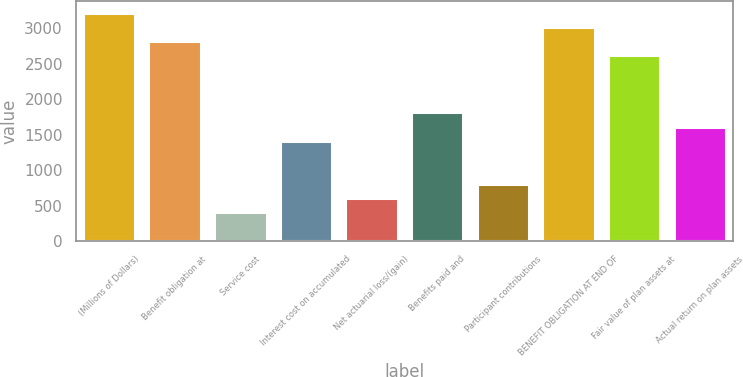<chart> <loc_0><loc_0><loc_500><loc_500><bar_chart><fcel>(Millions of Dollars)<fcel>Benefit obligation at<fcel>Service cost<fcel>Interest cost on accumulated<fcel>Net actuarial loss/(gain)<fcel>Benefits paid and<fcel>Participant contributions<fcel>BENEFIT OBLIGATION AT END OF<fcel>Fair value of plan assets at<fcel>Actual return on plan assets<nl><fcel>3218.2<fcel>2816.8<fcel>408.4<fcel>1411.9<fcel>609.1<fcel>1813.3<fcel>809.8<fcel>3017.5<fcel>2616.1<fcel>1612.6<nl></chart> 